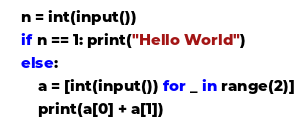<code> <loc_0><loc_0><loc_500><loc_500><_Python_>n = int(input())
if n == 1: print("Hello World")
else:
    a = [int(input()) for _ in range(2)]
    print(a[0] + a[1])</code> 